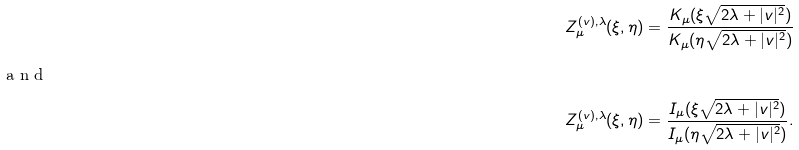<formula> <loc_0><loc_0><loc_500><loc_500>& Z _ { \mu } ^ { ( v ) , \lambda } ( \xi , \eta ) = \frac { K _ { \mu } ( \xi \sqrt { 2 \lambda + | v | ^ { 2 } } ) } { K _ { \mu } ( \eta \sqrt { 2 \lambda + | v | ^ { 2 } } ) } \\ \intertext { a n d } & Z _ { \mu } ^ { ( v ) , \lambda } ( \xi , \eta ) = \frac { I _ { \mu } ( \xi \sqrt { 2 \lambda + | v | ^ { 2 } } ) } { I _ { \mu } ( \eta \sqrt { 2 \lambda + | v | ^ { 2 } } ) } .</formula> 